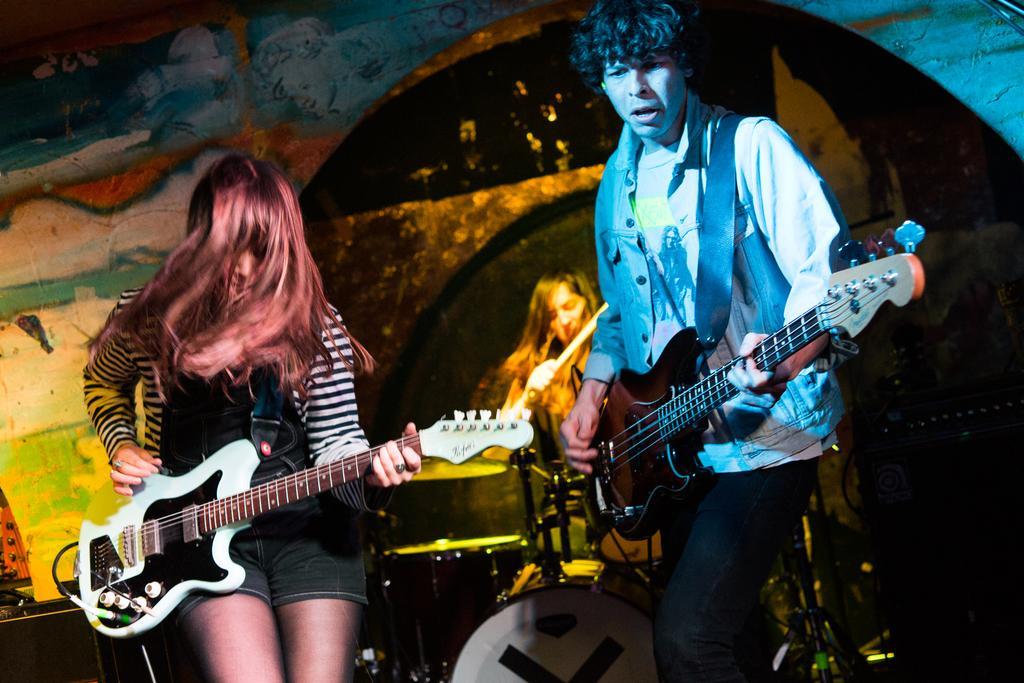Could you give a brief overview of what you see in this image? In this image I see a woman and a man who are holding guitars and In the background I see another who is holding sticks and is near to the drums and I see the wall on which there is art. 